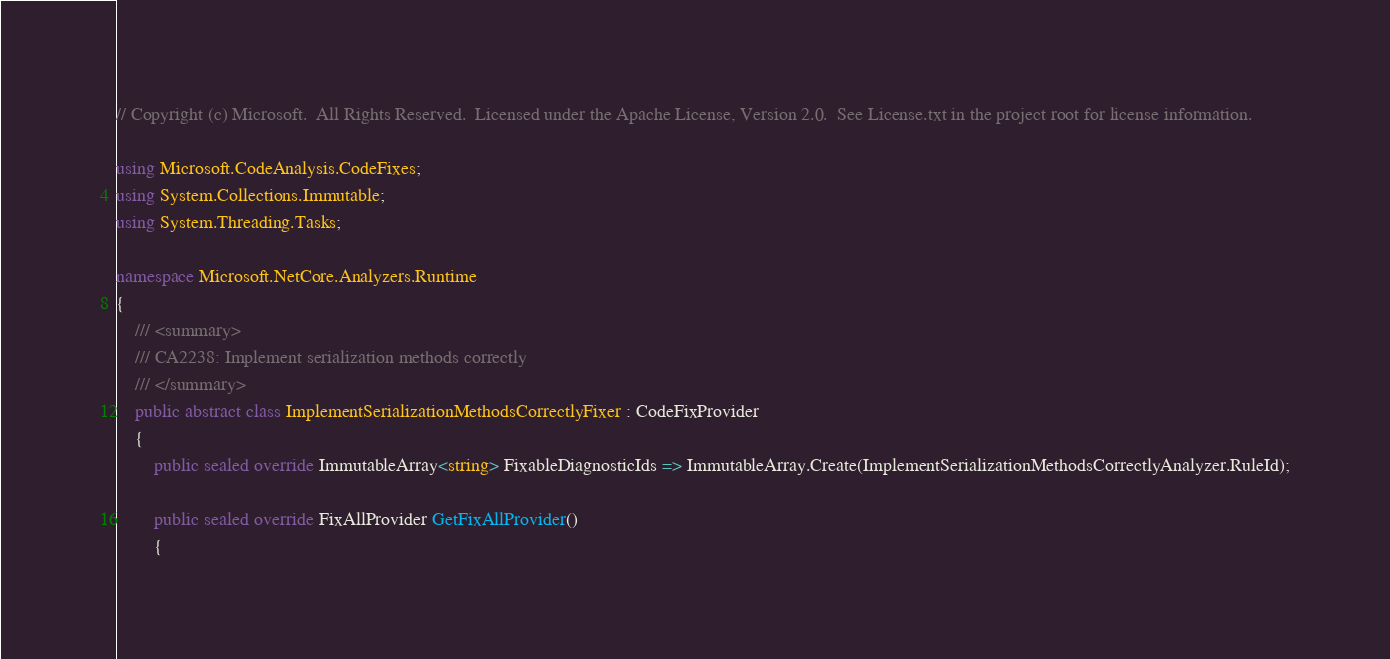Convert code to text. <code><loc_0><loc_0><loc_500><loc_500><_C#_>// Copyright (c) Microsoft.  All Rights Reserved.  Licensed under the Apache License, Version 2.0.  See License.txt in the project root for license information.

using Microsoft.CodeAnalysis.CodeFixes;
using System.Collections.Immutable;
using System.Threading.Tasks;

namespace Microsoft.NetCore.Analyzers.Runtime
{
    /// <summary>
    /// CA2238: Implement serialization methods correctly
    /// </summary>
    public abstract class ImplementSerializationMethodsCorrectlyFixer : CodeFixProvider
    {
        public sealed override ImmutableArray<string> FixableDiagnosticIds => ImmutableArray.Create(ImplementSerializationMethodsCorrectlyAnalyzer.RuleId);

        public sealed override FixAllProvider GetFixAllProvider()
        {</code> 